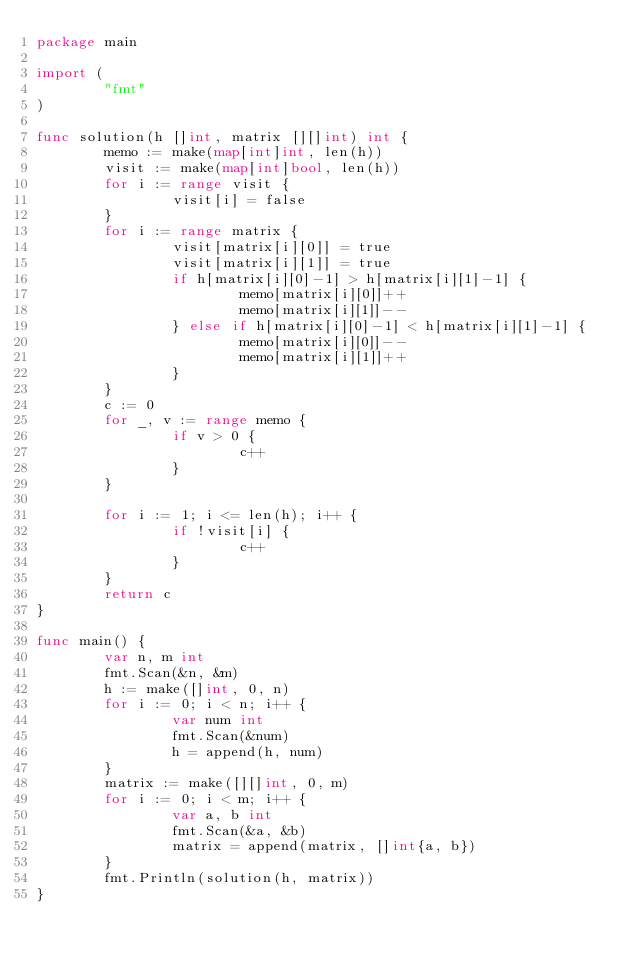Convert code to text. <code><loc_0><loc_0><loc_500><loc_500><_Go_>package main

import (
        "fmt"
)

func solution(h []int, matrix [][]int) int {
        memo := make(map[int]int, len(h))
        visit := make(map[int]bool, len(h))
        for i := range visit {
                visit[i] = false
        }
        for i := range matrix {
                visit[matrix[i][0]] = true
                visit[matrix[i][1]] = true
                if h[matrix[i][0]-1] > h[matrix[i][1]-1] {
                        memo[matrix[i][0]]++
                        memo[matrix[i][1]]--
                } else if h[matrix[i][0]-1] < h[matrix[i][1]-1] {
                        memo[matrix[i][0]]--
                        memo[matrix[i][1]]++
                }
        }
        c := 0
        for _, v := range memo {
                if v > 0 {
                        c++
                }
        }

        for i := 1; i <= len(h); i++ {
                if !visit[i] {
                        c++
                }
        }
        return c
}

func main() {
        var n, m int
        fmt.Scan(&n, &m)
        h := make([]int, 0, n)
        for i := 0; i < n; i++ {
                var num int
                fmt.Scan(&num)
                h = append(h, num)
        }
        matrix := make([][]int, 0, m)
        for i := 0; i < m; i++ {
                var a, b int
                fmt.Scan(&a, &b)
                matrix = append(matrix, []int{a, b})
        }
        fmt.Println(solution(h, matrix))
}</code> 